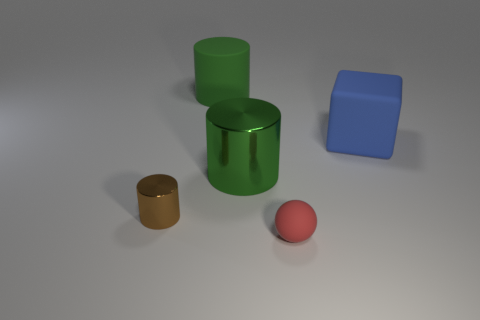Add 4 purple metal cubes. How many objects exist? 9 Subtract all spheres. How many objects are left? 4 Add 1 green matte cylinders. How many green matte cylinders are left? 2 Add 1 spheres. How many spheres exist? 2 Subtract 0 red cylinders. How many objects are left? 5 Subtract all big objects. Subtract all green cylinders. How many objects are left? 0 